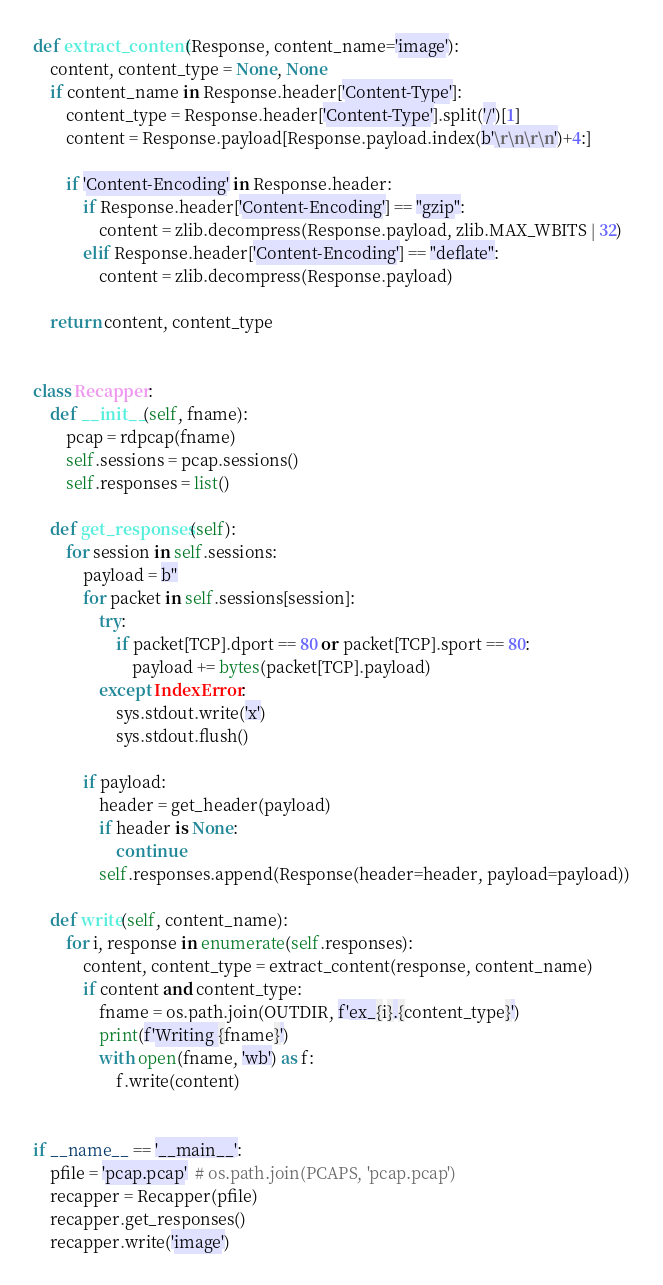Convert code to text. <code><loc_0><loc_0><loc_500><loc_500><_Python_>
def extract_content(Response, content_name='image'):
    content, content_type = None, None
    if content_name in Response.header['Content-Type']:
        content_type = Response.header['Content-Type'].split('/')[1]
        content = Response.payload[Response.payload.index(b'\r\n\r\n')+4:]

        if 'Content-Encoding' in Response.header:
            if Response.header['Content-Encoding'] == "gzip":
                content = zlib.decompress(Response.payload, zlib.MAX_WBITS | 32)
            elif Response.header['Content-Encoding'] == "deflate":
                content = zlib.decompress(Response.payload)

    return content, content_type


class Recapper:
    def __init__(self, fname):
        pcap = rdpcap(fname)
        self.sessions = pcap.sessions()
        self.responses = list()

    def get_responses(self):
        for session in self.sessions:
            payload = b''
            for packet in self.sessions[session]:
                try:
                    if packet[TCP].dport == 80 or packet[TCP].sport == 80:
                        payload += bytes(packet[TCP].payload)
                except IndexError:
                    sys.stdout.write('x')
                    sys.stdout.flush()

            if payload:
                header = get_header(payload)
                if header is None:
                    continue
                self.responses.append(Response(header=header, payload=payload))

    def write(self, content_name):
        for i, response in enumerate(self.responses):
            content, content_type = extract_content(response, content_name)
            if content and content_type:
                fname = os.path.join(OUTDIR, f'ex_{i}.{content_type}')
                print(f'Writing {fname}')
                with open(fname, 'wb') as f:
                    f.write(content)


if __name__ == '__main__':
    pfile = 'pcap.pcap'  # os.path.join(PCAPS, 'pcap.pcap')
    recapper = Recapper(pfile)
    recapper.get_responses()
    recapper.write('image')
</code> 